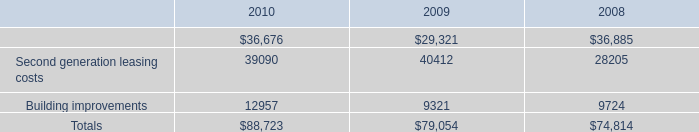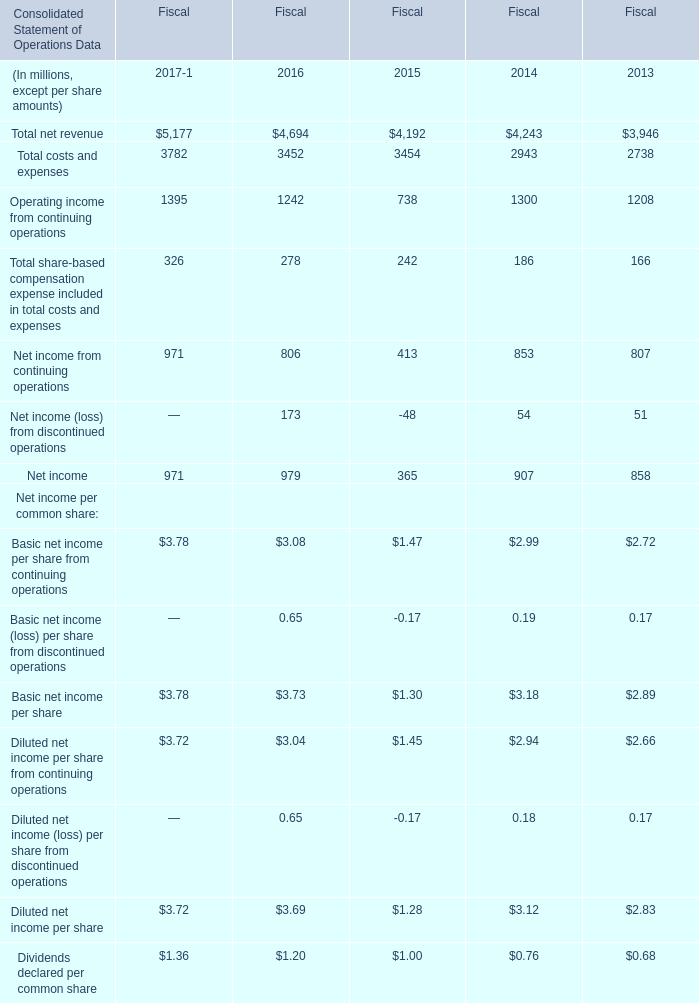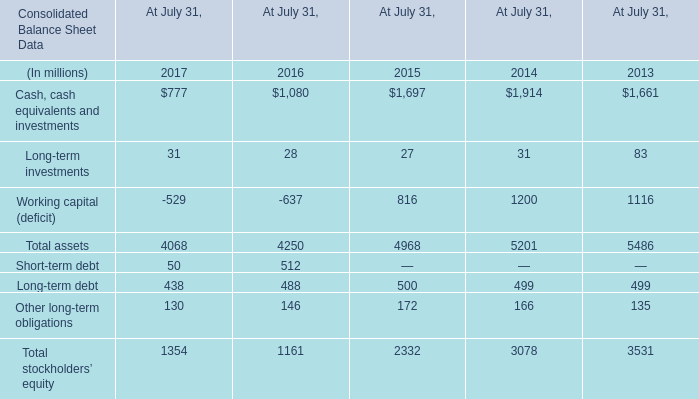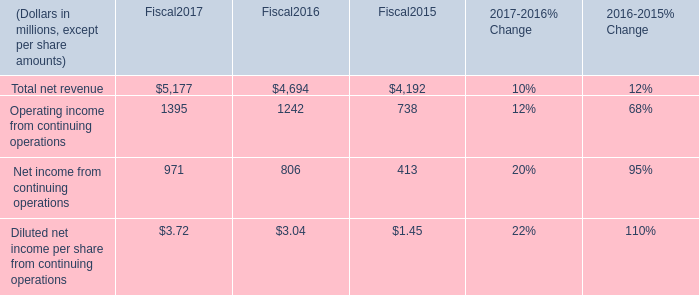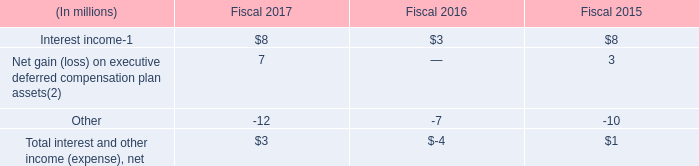In the year with the most Net income from continuing operations, what is the growth rate ofNet income? 
Computations: ((971 - 979) / 971)
Answer: -0.00824. 